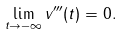<formula> <loc_0><loc_0><loc_500><loc_500>\lim _ { t \to - \infty } v ^ { \prime \prime \prime } ( t ) = 0 .</formula> 